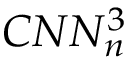Convert formula to latex. <formula><loc_0><loc_0><loc_500><loc_500>C N N _ { n } ^ { 3 }</formula> 